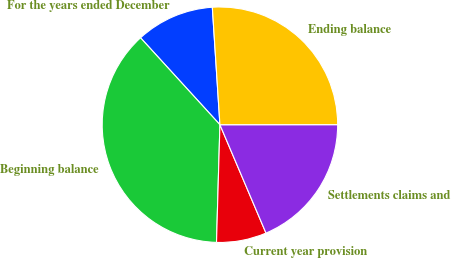Convert chart. <chart><loc_0><loc_0><loc_500><loc_500><pie_chart><fcel>For the years ended December<fcel>Beginning balance<fcel>Current year provision<fcel>Settlements claims and<fcel>Ending balance<nl><fcel>10.75%<fcel>37.76%<fcel>6.86%<fcel>18.61%<fcel>26.02%<nl></chart> 